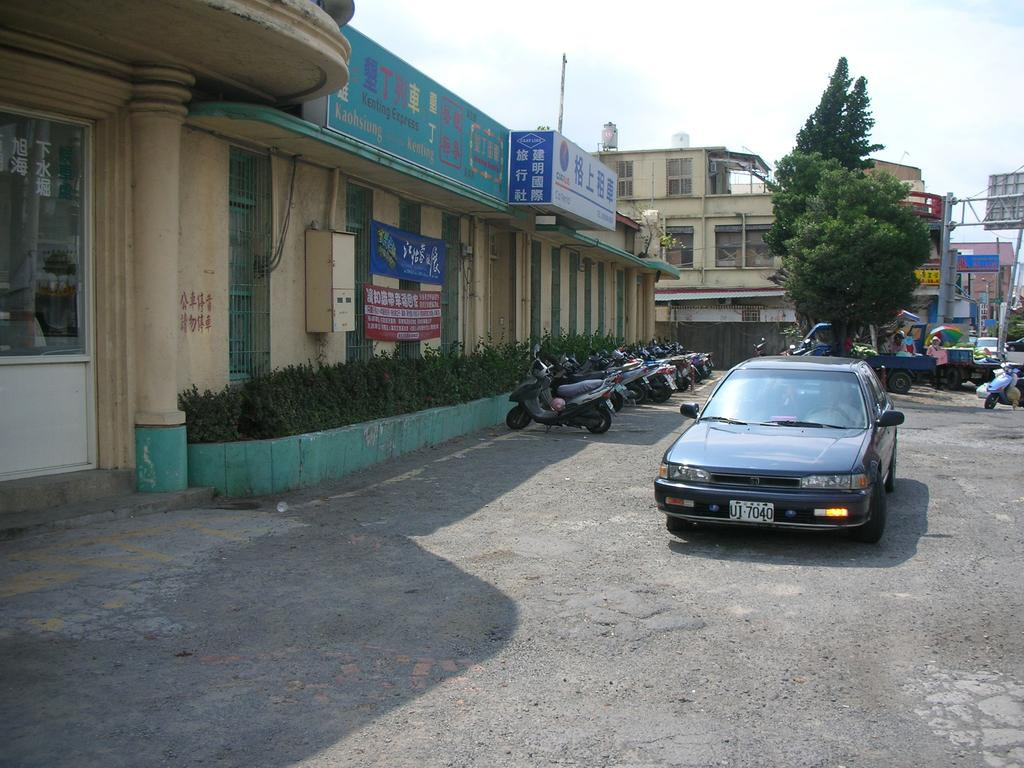What types of objects are on the ground in the image? There are vehicles on the ground in the image. What can be seen in the background of the image? There are buildings, trees, banners, and the sky visible in the background of the image. Can you describe the unspecified objects in the background of the image? Unfortunately, the provided facts do not specify the nature of these objects. What type of trousers is the moon wearing in the image? There is no moon present in the image, and therefore no trousers can be observed. How does the pest affect the vehicles in the image? There is no mention of a pest in the image, so its impact on the vehicles cannot be determined. 